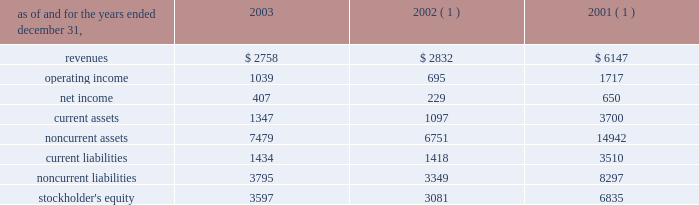In the fourth quarter of 2002 , aes lost voting control of one of the holding companies in the cemig ownership structure .
This holding company indirectly owns the shares related to the cemig investment and indirectly holds the project financing debt related to cemig .
As a result of the loss of voting control , aes stopped consolidating this holding company at december 31 , 2002 .
Other .
During the fourth quarter of 2003 , the company sold its 25% ( 25 % ) ownership interest in medway power limited ( 2018 2018mpl 2019 2019 ) , a 688 mw natural gas-fired combined cycle facility located in the united kingdom , and aes medway operations limited ( 2018 2018aesmo 2019 2019 ) , the operating company for the facility , in an aggregate transaction valued at approximately a347 million ( $ 78 million ) .
The sale resulted in a gain of $ 23 million which was recorded in continuing operations .
Mpl and aesmo were previously reported in the contract generation segment .
In the second quarter of 2002 , the company sold its investment in empresa de infovias s.a .
( 2018 2018infovias 2019 2019 ) , a telecommunications company in brazil , for proceeds of $ 31 million to cemig , an affiliated company .
The loss recorded on the sale was approximately $ 14 million and is recorded as a loss on sale of assets and asset impairment expenses in the accompanying consolidated statements of operations .
In the second quarter of 2002 , the company recorded an impairment charge of approximately $ 40 million , after income taxes , on an equity method investment in a telecommunications company in latin america held by edc .
The impairment charge resulted from sustained poor operating performance coupled with recent funding problems at the invested company .
During 2001 , the company lost operational control of central electricity supply corporation ( 2018 2018cesco 2019 2019 ) , a distribution company located in the state of orissa , india .
The state of orissa appointed an administrator to take operational control of cesco .
Cesco is accounted for as a cost method investment .
Aes 2019s investment in cesco is negative .
In august 2000 , a subsidiary of the company acquired a 49% ( 49 % ) interest in songas for approximately $ 40 million .
The company acquired an additional 16.79% ( 16.79 % ) of songas for approximately $ 12.5 million , and the company began consolidating this entity in 2002 .
Songas owns the songo songo gas-to-electricity project in tanzania .
In december 2002 , the company signed a sales purchase agreement to sell 100% ( 100 % ) of our ownership interest in songas .
The sale of songas closed in april 2003 ( see note 4 for further discussion of the transaction ) .
The tables present summarized comparative financial information ( in millions ) of the entities in which the company has the ability to exercise significant influence but does not control and that are accounted for using the equity method. .
( 1 ) includes information pertaining to eletropaulo and light prior to february 2002 .
In 2002 and 2001 , the results of operations and the financial position of cemig were negatively impacted by the devaluation of the brazilian real and the impairment charge recorded in 2002 .
The brazilian real devalued 32% ( 32 % ) and 19% ( 19 % ) for the years ended december 31 , 2002 and 2001 , respectively. .
What was the percentage change in operating income for entities in which the company has the ability to exercise significant influence but does not control and that are accounted for using the equity method between 2001 and 2002? 
Computations: ((695 - 1717) / 1717)
Answer: -0.59522. 